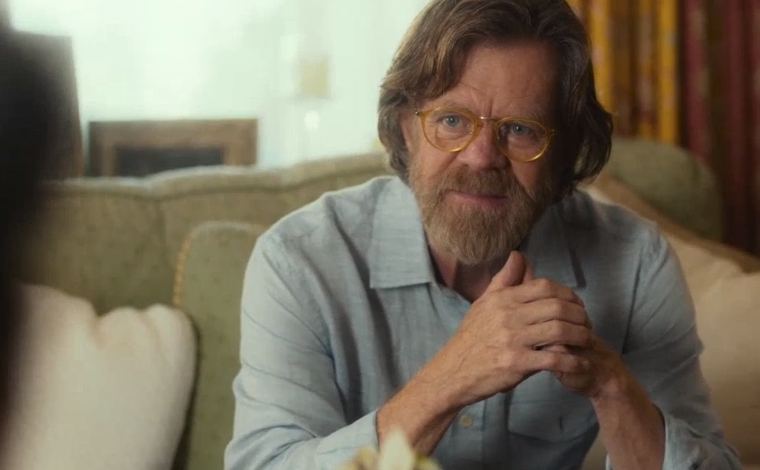Imagine a creative story that could explain the context of the image. Once upon a time, in a small coastal town, a retired professor named sharegpt4v/samuel Turner spent his twilight years mentoring young writers. One afternoon, seated in his familiar green armchair, he shared tales from his traveling days. As the fireplace remained unlit but ready for the evening’s chill, the warm sunlight streamed through the patterned curtains. The room held many memories, each item a souvenir from a chapter of his life. sharegpt4v/samuel's eyes sparkled behind his glasses as he narrated a story about a lost manuscript, captivating his audience who hung onto every word from the old storyteller. What objects in the room might hold special significance to the man? The green armchair he sits in could be a cherished heirloom, passed down through generations. The fireplace, though not currently in use, could symbolize warmth and family gatherings over the years. The patterned curtains may have been chosen by a loved one or remind him of a place he once visited. Each of these details adds layers to the narrative of the man’s life and the stories he might share. If this scene was part of a film, what could be happening in this scene? In a film, this scene could be a pivotal moment where the main character reminisces about his past, offering wisdom and advice to a younger character. The intimate setting, with its warm lighting and cozy ambiance, sets the stage for a heart-to-heart conversation where life lessons are shared, and a deeper connection is forged between the characters. This scene might be the catalyst for significant growth or change in the storyline, highlighting the emotional and narrative depth of the film. 